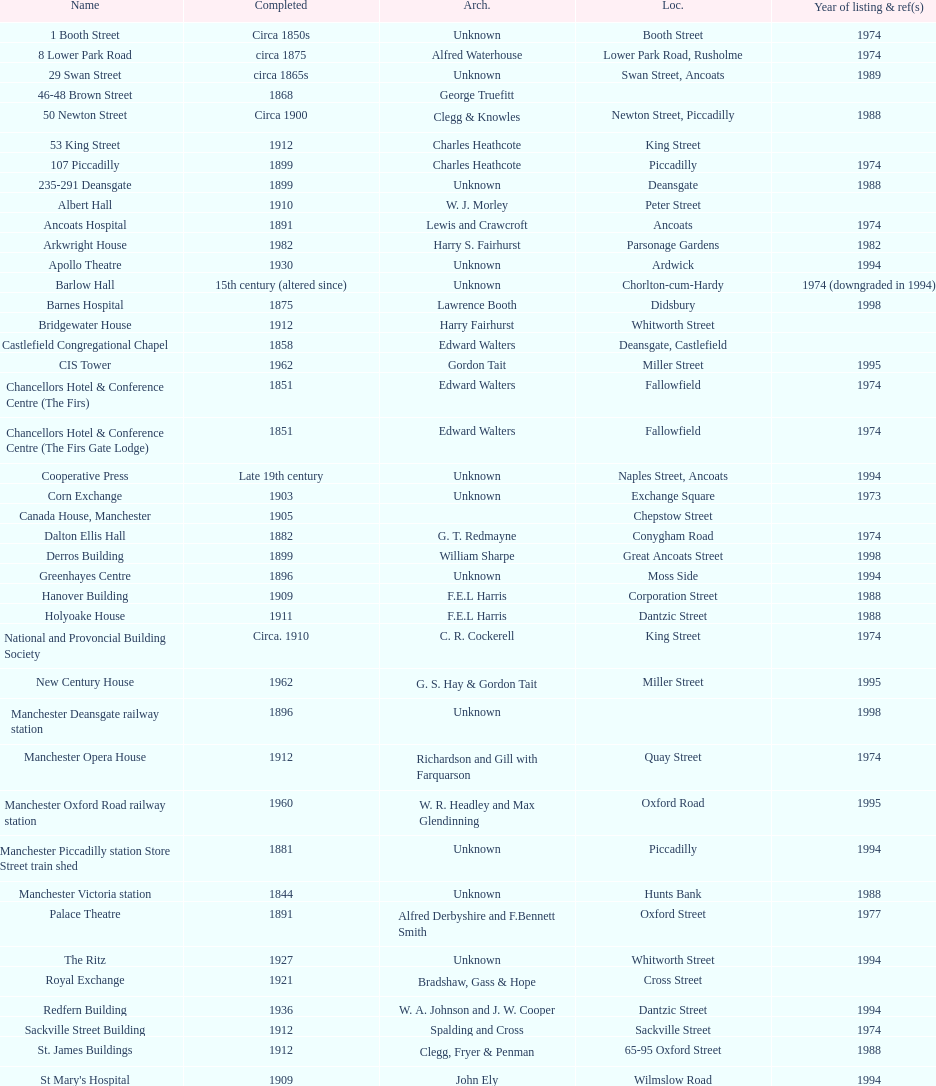Which year has the most buildings listed? 1974. 